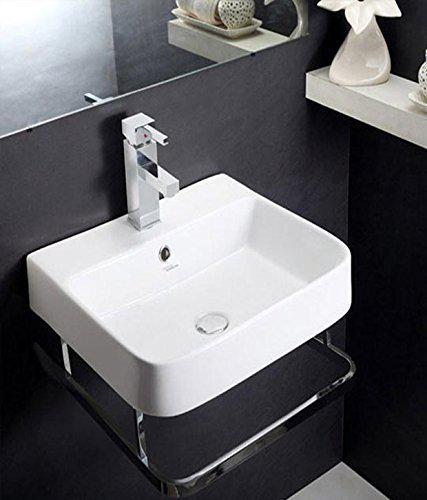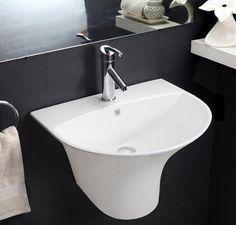The first image is the image on the left, the second image is the image on the right. For the images shown, is this caption "In one of the images, there is a freestanding white sink with a shelf underneath and chrome legs." true? Answer yes or no. No. The first image is the image on the left, the second image is the image on the right. Evaluate the accuracy of this statement regarding the images: "There is a shelf under the sink in one of the images.". Is it true? Answer yes or no. No. 